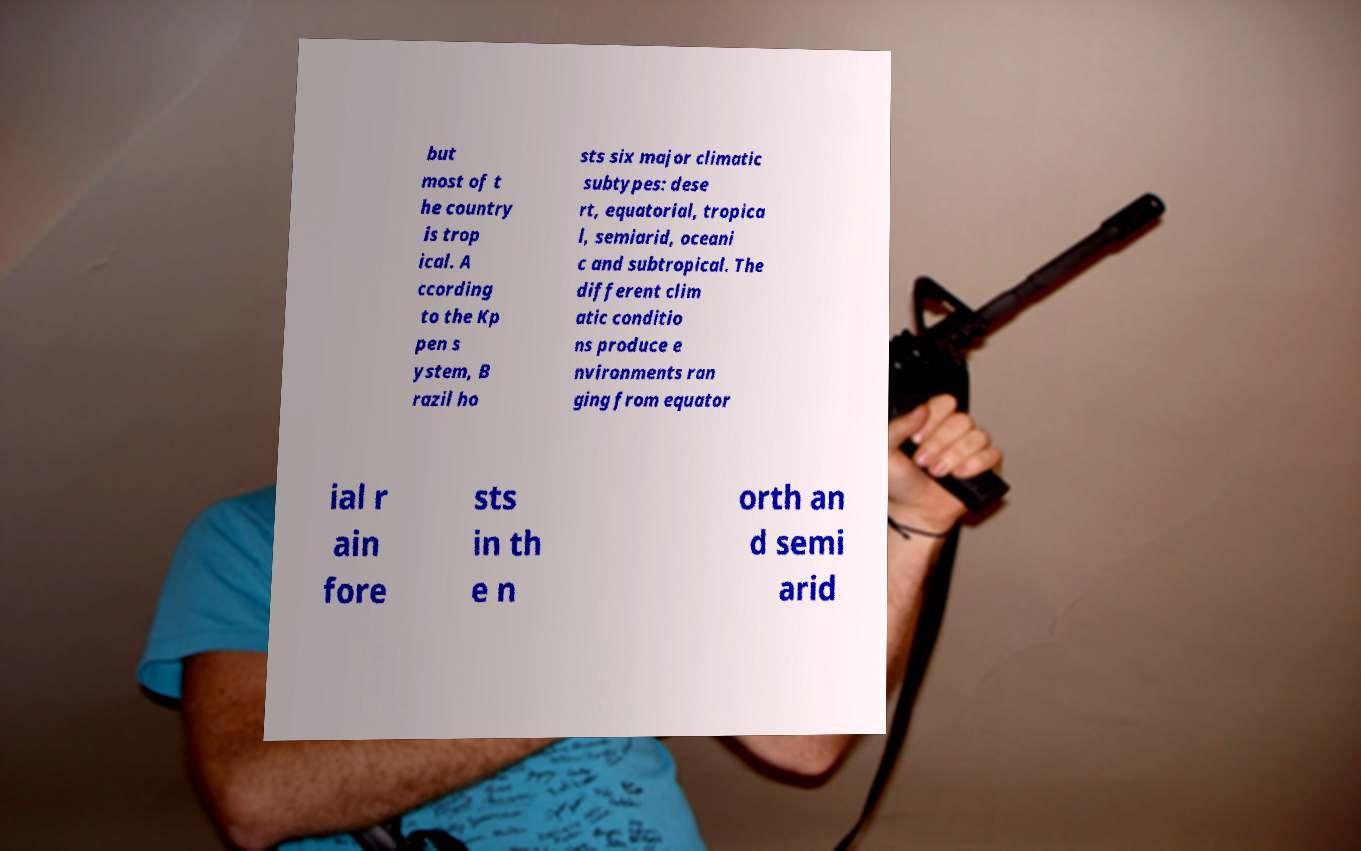Please identify and transcribe the text found in this image. but most of t he country is trop ical. A ccording to the Kp pen s ystem, B razil ho sts six major climatic subtypes: dese rt, equatorial, tropica l, semiarid, oceani c and subtropical. The different clim atic conditio ns produce e nvironments ran ging from equator ial r ain fore sts in th e n orth an d semi arid 